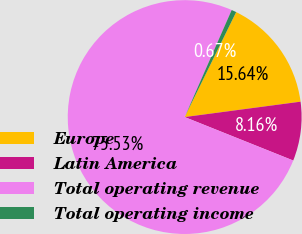<chart> <loc_0><loc_0><loc_500><loc_500><pie_chart><fcel>Europe<fcel>Latin America<fcel>Total operating revenue<fcel>Total operating income<nl><fcel>15.64%<fcel>8.16%<fcel>75.52%<fcel>0.67%<nl></chart> 